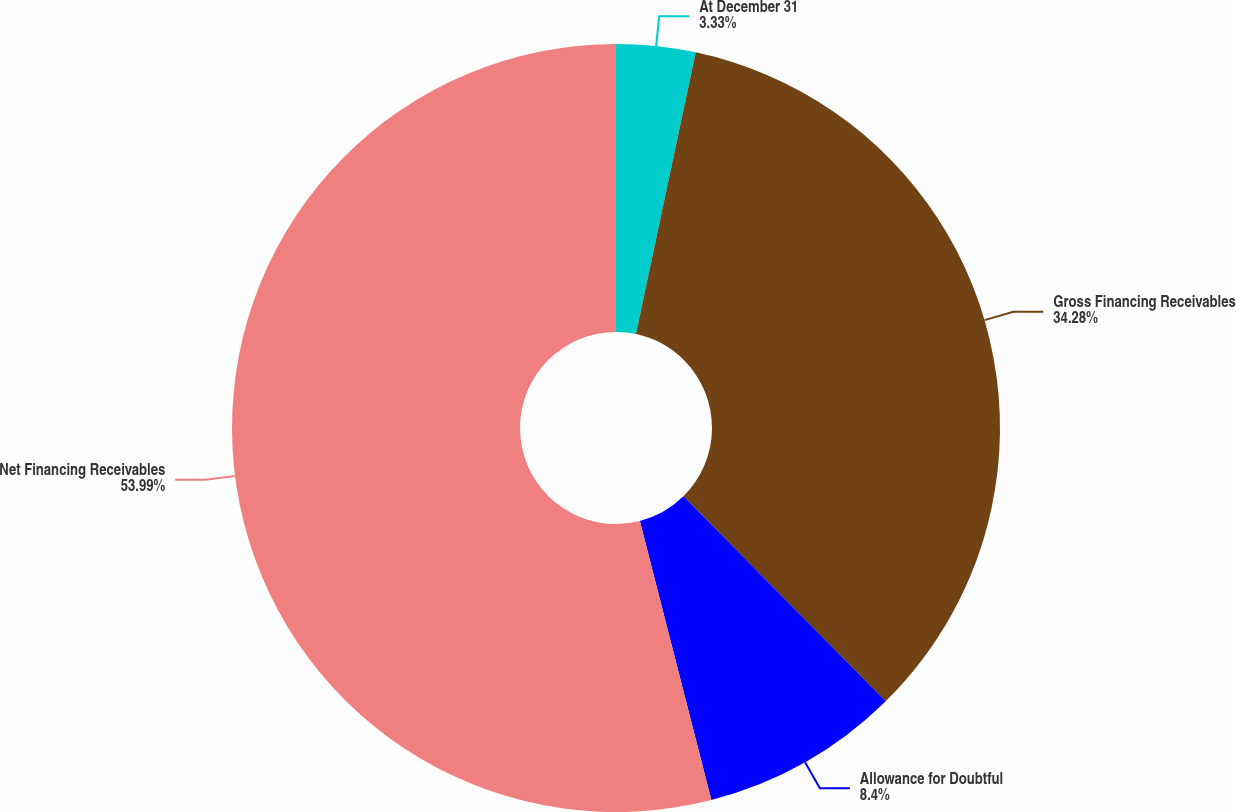Convert chart to OTSL. <chart><loc_0><loc_0><loc_500><loc_500><pie_chart><fcel>At December 31<fcel>Gross Financing Receivables<fcel>Allowance for Doubtful<fcel>Net Financing Receivables<nl><fcel>3.33%<fcel>34.28%<fcel>8.4%<fcel>54.0%<nl></chart> 